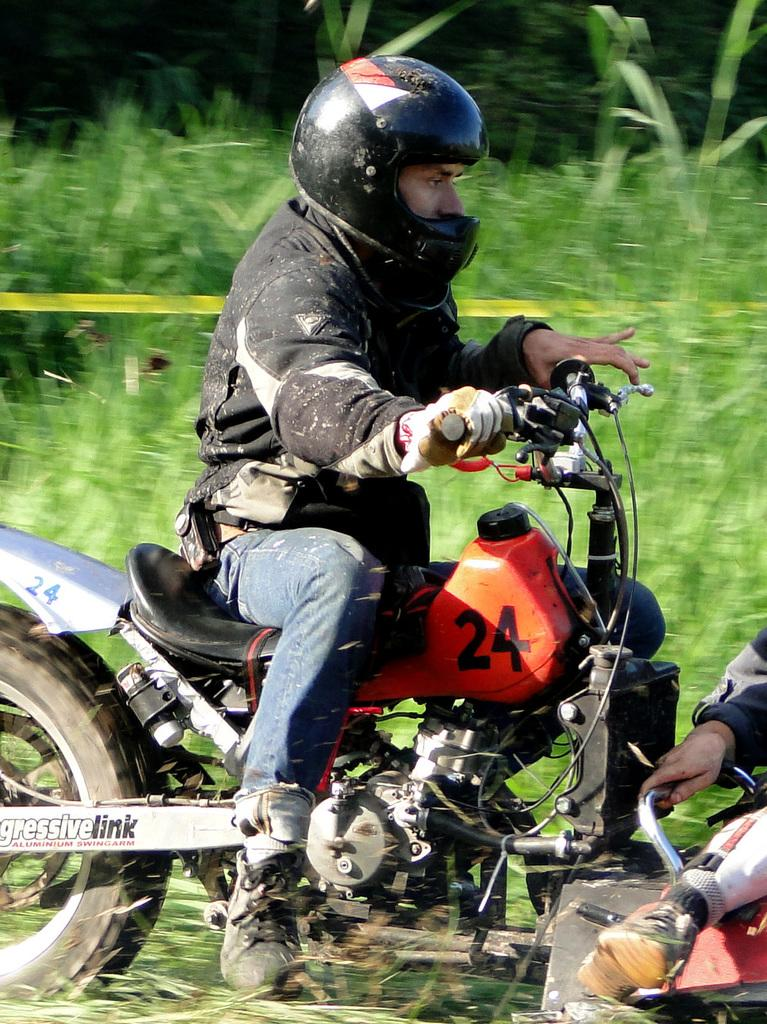What is the main subject of the image? There is a person in the image. What protective gear is the person wearing? The person is wearing a glove and a helmet. What mode of transportation is the person using? The person is riding a motorcycle. Can you describe any identifying features of the motorcycle? There is a number on the motorcycle. How would you describe the background of the image? The background is green and blurred. What type of reaction can be seen from the spring in the image? There is no spring present in the image; it features a person riding a motorcycle. How many stockings is the person wearing in the image? The person is wearing a glove, not a stocking, in the image. 